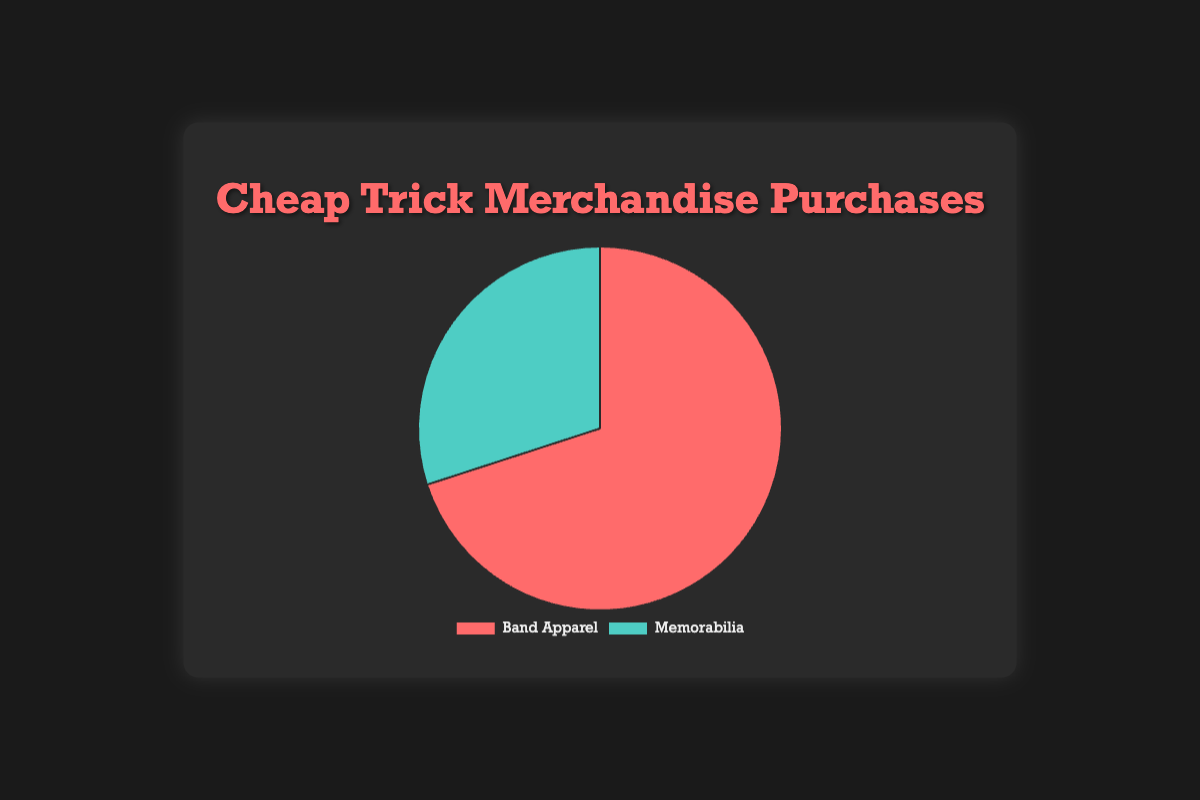What percentage of merchandise purchases is for Band Apparel? The pie chart shows that Band Apparel accounts for 70% of the merchandise purchases.
Answer: 70% What percentage of merchandise purchases is for Memorabilia? The pie chart shows that Memorabilia accounts for 30% of the merchandise purchases.
Answer: 30% Is Band Apparel purchased more frequently than Memorabilia? By looking at the pie chart, it is clear that Band Apparel has a larger slice (70%) compared to Memorabilia (30%).
Answer: Yes What is the ratio of Band Apparel purchases to Memorabilia purchases? To find the ratio, divide the percentage of Band Apparel by the percentage of Memorabilia, which is 70/30 = 7/3.
Answer: 7:3 How much more popular is Band Apparel than Memorabilia in percentage points? Subtract the percentage for Memorabilia from the percentage for Band Apparel: 70% - 30% = 40%.
Answer: 40% If the total number of merchandise purchases is 100, how many would be for Band Apparel? Since Band Apparel accounts for 70% of purchases, 70 out of 100 purchases would be for Band Apparel.
Answer: 70 What fraction of the total purchases does Memorabilia constitute? Memorabilia constitutes 30% of the total purchases; hence, it makes up 30/100 = 3/10 of the total purchases.
Answer: 3/10 Which section has a larger area, the red section or the green section? The red section represents Band Apparel (70%), which is larger than the green section representing Memorabilia (30%).
Answer: Red section If 200 items were purchased, how many of them would be Memorabilia? Memorabilia accounts for 30% of the purchases, so 0.30 * 200 = 60 items would be Memorabilia.
Answer: 60 What is the sum of the percentages of Band Apparel and Memorabilia purchases? Adding the percentage of Band Apparel (70%) and Memorabilia (30%) gives a total of 70% + 30% = 100%.
Answer: 100% 